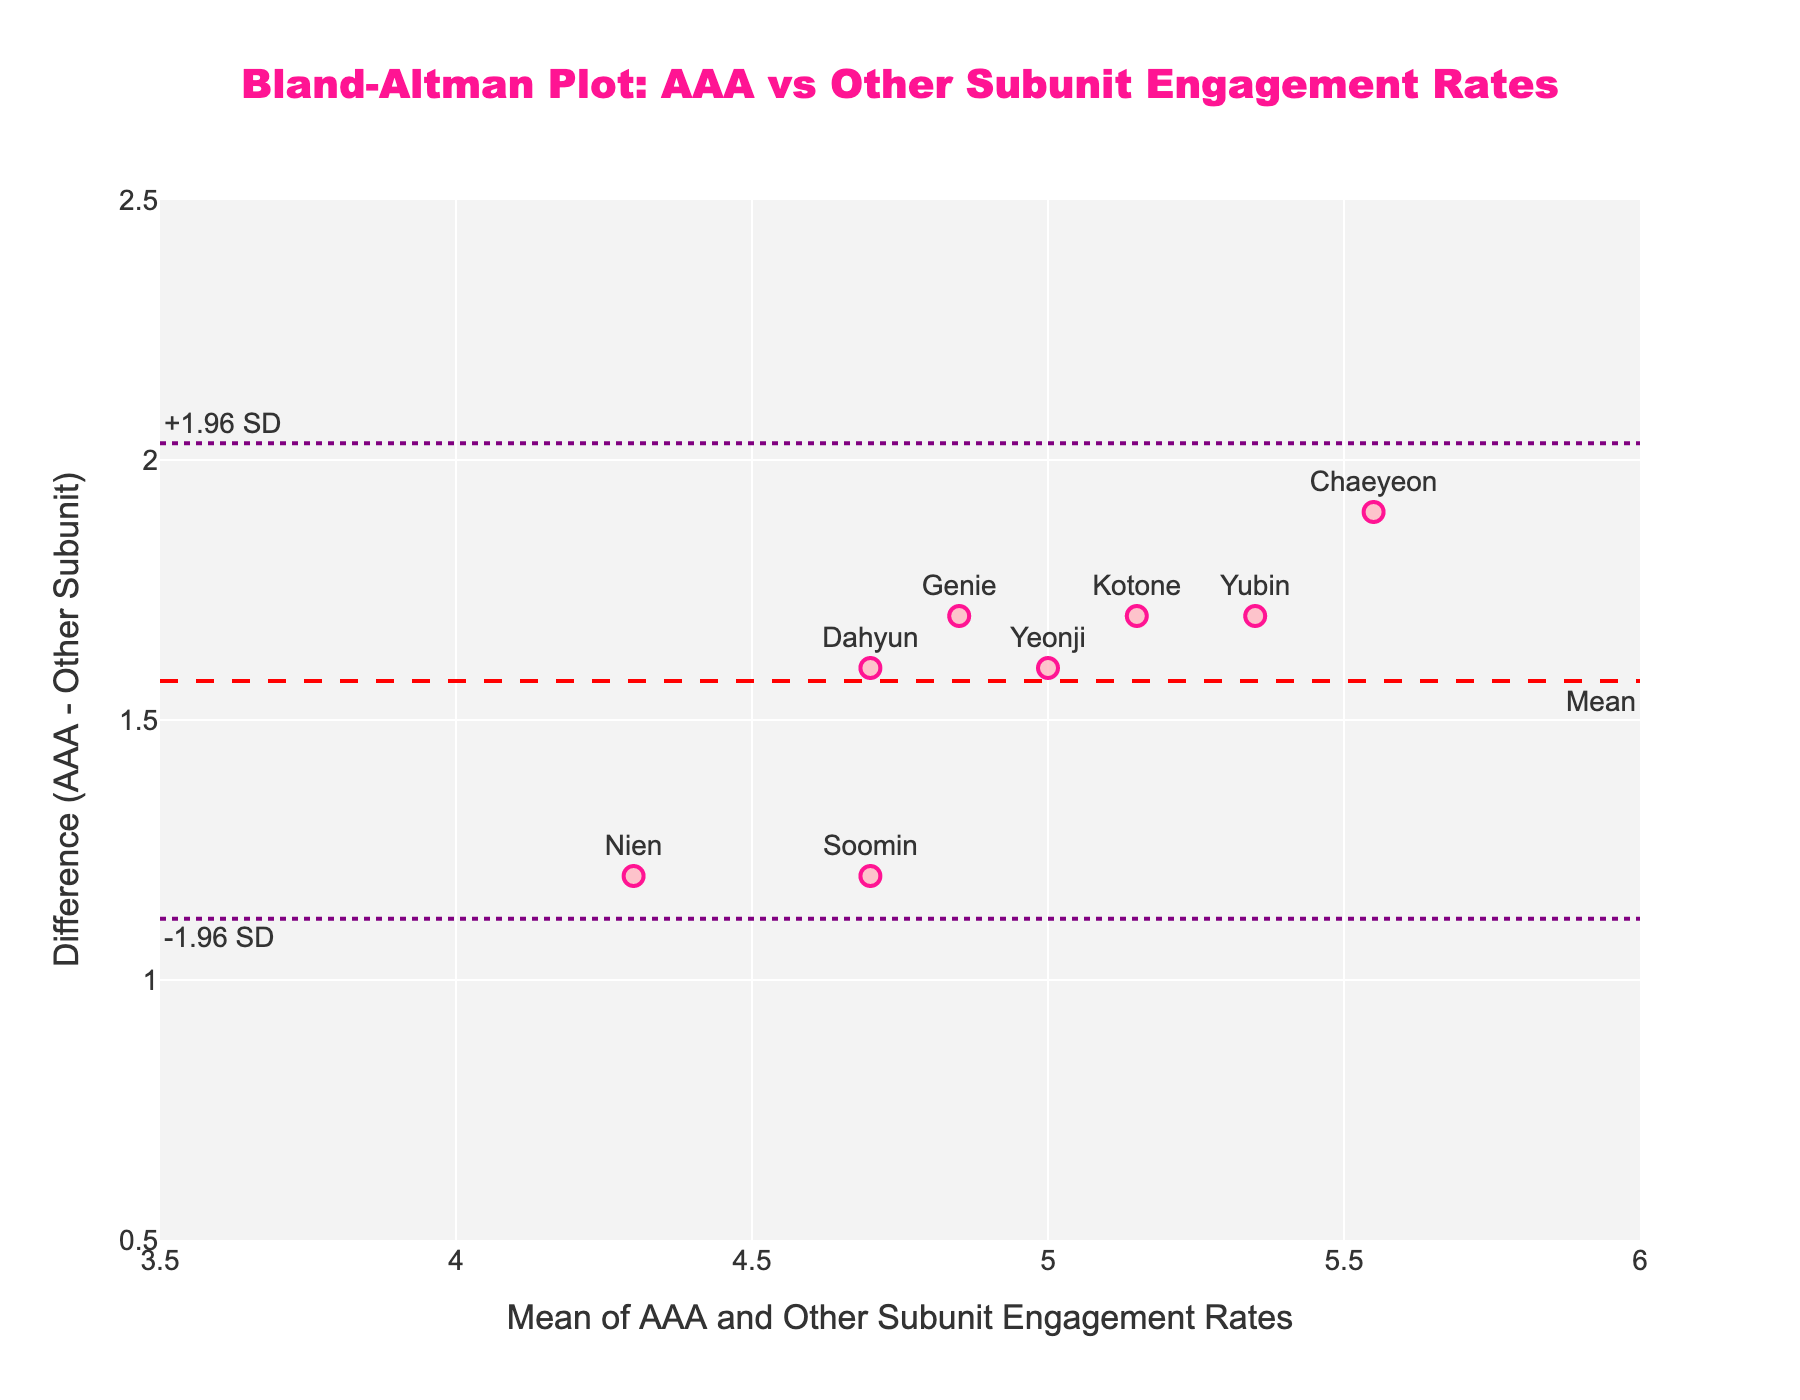What is the title of the figure? The title is located at the top of the plot and is written in a large, bold font. It reads "Bland-Altman Plot: AAA vs Other Subunit Engagement Rates".
Answer: Bland-Altman Plot: AAA vs Other Subunit Engagement Rates Which member has the highest engagement rate difference between AAA and the other subunits? Look at the y-axis values and identify the member with the largest positive difference value. Chaeyeon has the highest engagement rate difference at the top of the plot.
Answer: Chaeyeon How many data points are plotted in the figure? Count the number of markers representing the data points in the scatter plot. There are 8 markers, one for each member.
Answer: 8 What is the mean difference between AAA and Other Subunit engagement rates? The mean difference is represented by the dashed red horizontal line, annotated with "Mean" at the bottom right. It is visually located slightly above 1.2 on the y-axis.
Answer: ~1.325 What are the limits of agreement in the plot? The limits of agreement are represented by the dotted purple horizontal lines, labeled "-1.96 SD" and "1.96 SD". Visually, these lines are approximately at y-values around 0.775 and 1.875.
Answer: ~0.775 and ~1.875 Which member's engagement rate difference is closest to the mean difference? Compare the data points with the mean difference line. Yeonji's data point is closest to the mean difference line at around y = 1.6.
Answer: Yeonji What is the range of the x-axis (mean engagement rates)? Look at the x-axis and identify the minimum and maximum values marked on the axis. The range is from 3.5 to 6.
Answer: 3.5 to 6 Are there any data points outside the limits of agreement? Observe if any data points are plotted outside the dotted purple lines representing the limits of agreement. All data points are within these lines.
Answer: No Which two members have the smallest difference in their engagement rates? Compare all data points and identify the ones closest to the x-axis (smallest y-values). Nien and Dahyun have the smallest difference in their engagement rates with values close to 1.2.
Answer: Nien and Dahyun Is the overall trend of AAA engagement rates higher or lower compared to the other subunits? Majority of the data points are above the x-axis indicating that AAA engagement rates are mostly higher.
Answer: Higher 